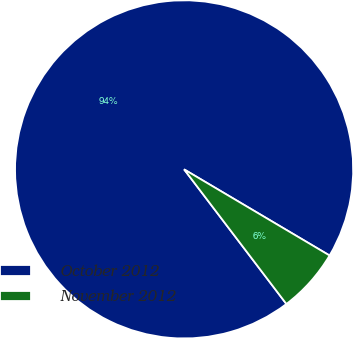Convert chart. <chart><loc_0><loc_0><loc_500><loc_500><pie_chart><fcel>October 2012<fcel>November 2012<nl><fcel>93.85%<fcel>6.15%<nl></chart> 